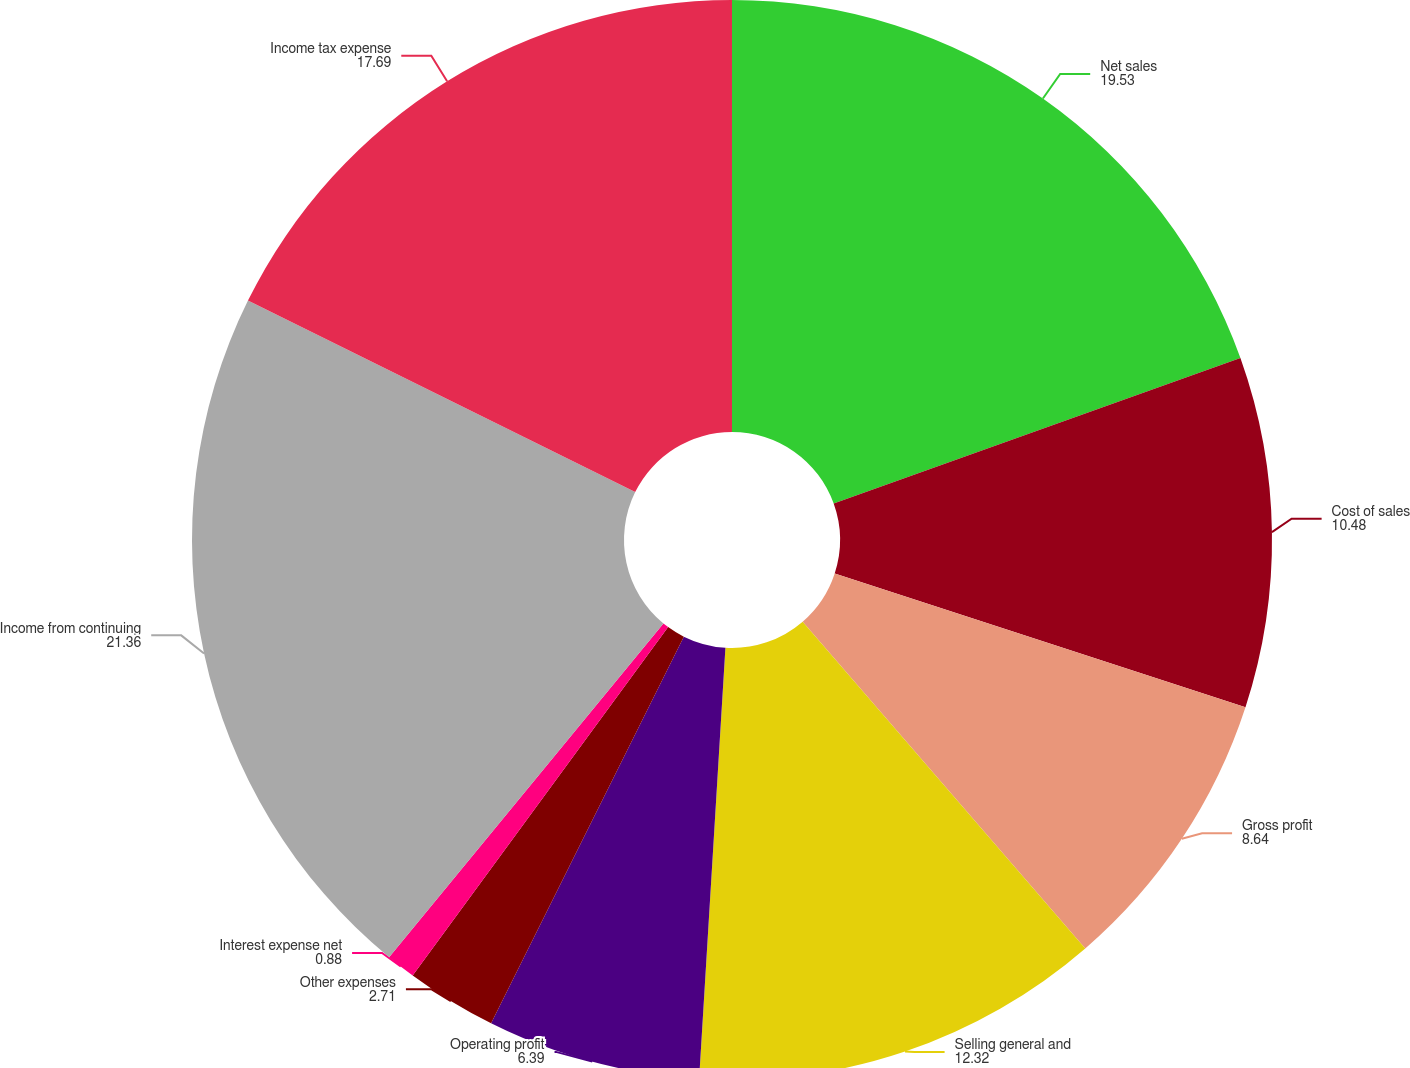Convert chart. <chart><loc_0><loc_0><loc_500><loc_500><pie_chart><fcel>Net sales<fcel>Cost of sales<fcel>Gross profit<fcel>Selling general and<fcel>Operating profit<fcel>Other expenses<fcel>Interest expense net<fcel>Income from continuing<fcel>Income tax expense<nl><fcel>19.53%<fcel>10.48%<fcel>8.64%<fcel>12.32%<fcel>6.39%<fcel>2.71%<fcel>0.88%<fcel>21.36%<fcel>17.69%<nl></chart> 